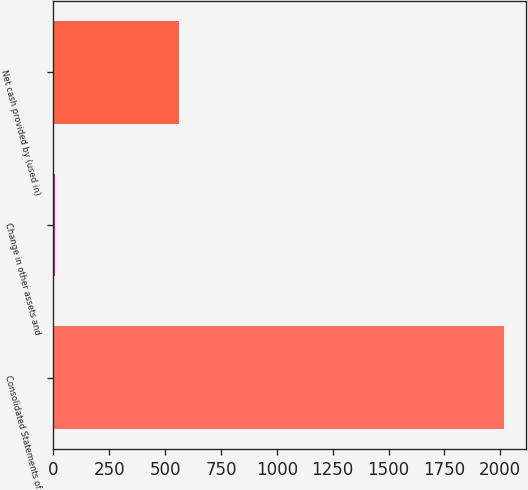Convert chart to OTSL. <chart><loc_0><loc_0><loc_500><loc_500><bar_chart><fcel>Consolidated Statements of<fcel>Change in other assets and<fcel>Net cash provided by (used in)<nl><fcel>2015<fcel>8.9<fcel>561.6<nl></chart> 